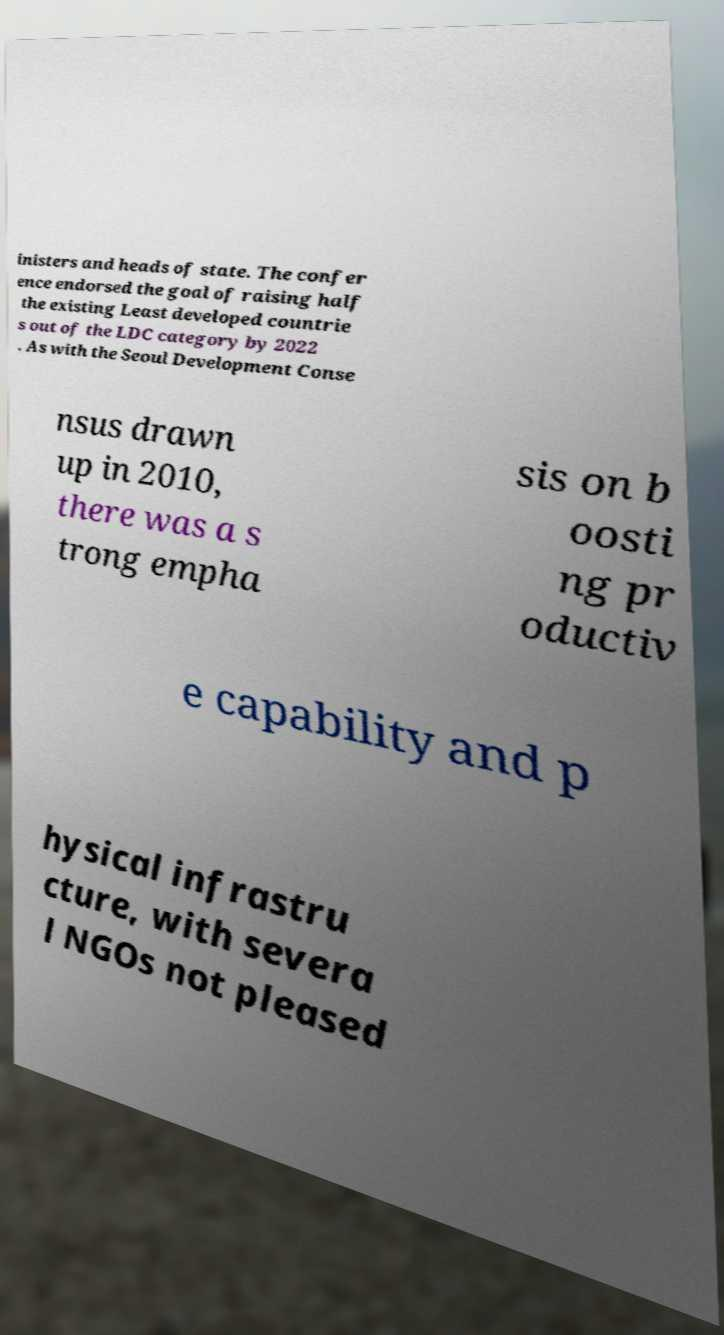For documentation purposes, I need the text within this image transcribed. Could you provide that? inisters and heads of state. The confer ence endorsed the goal of raising half the existing Least developed countrie s out of the LDC category by 2022 . As with the Seoul Development Conse nsus drawn up in 2010, there was a s trong empha sis on b oosti ng pr oductiv e capability and p hysical infrastru cture, with severa l NGOs not pleased 